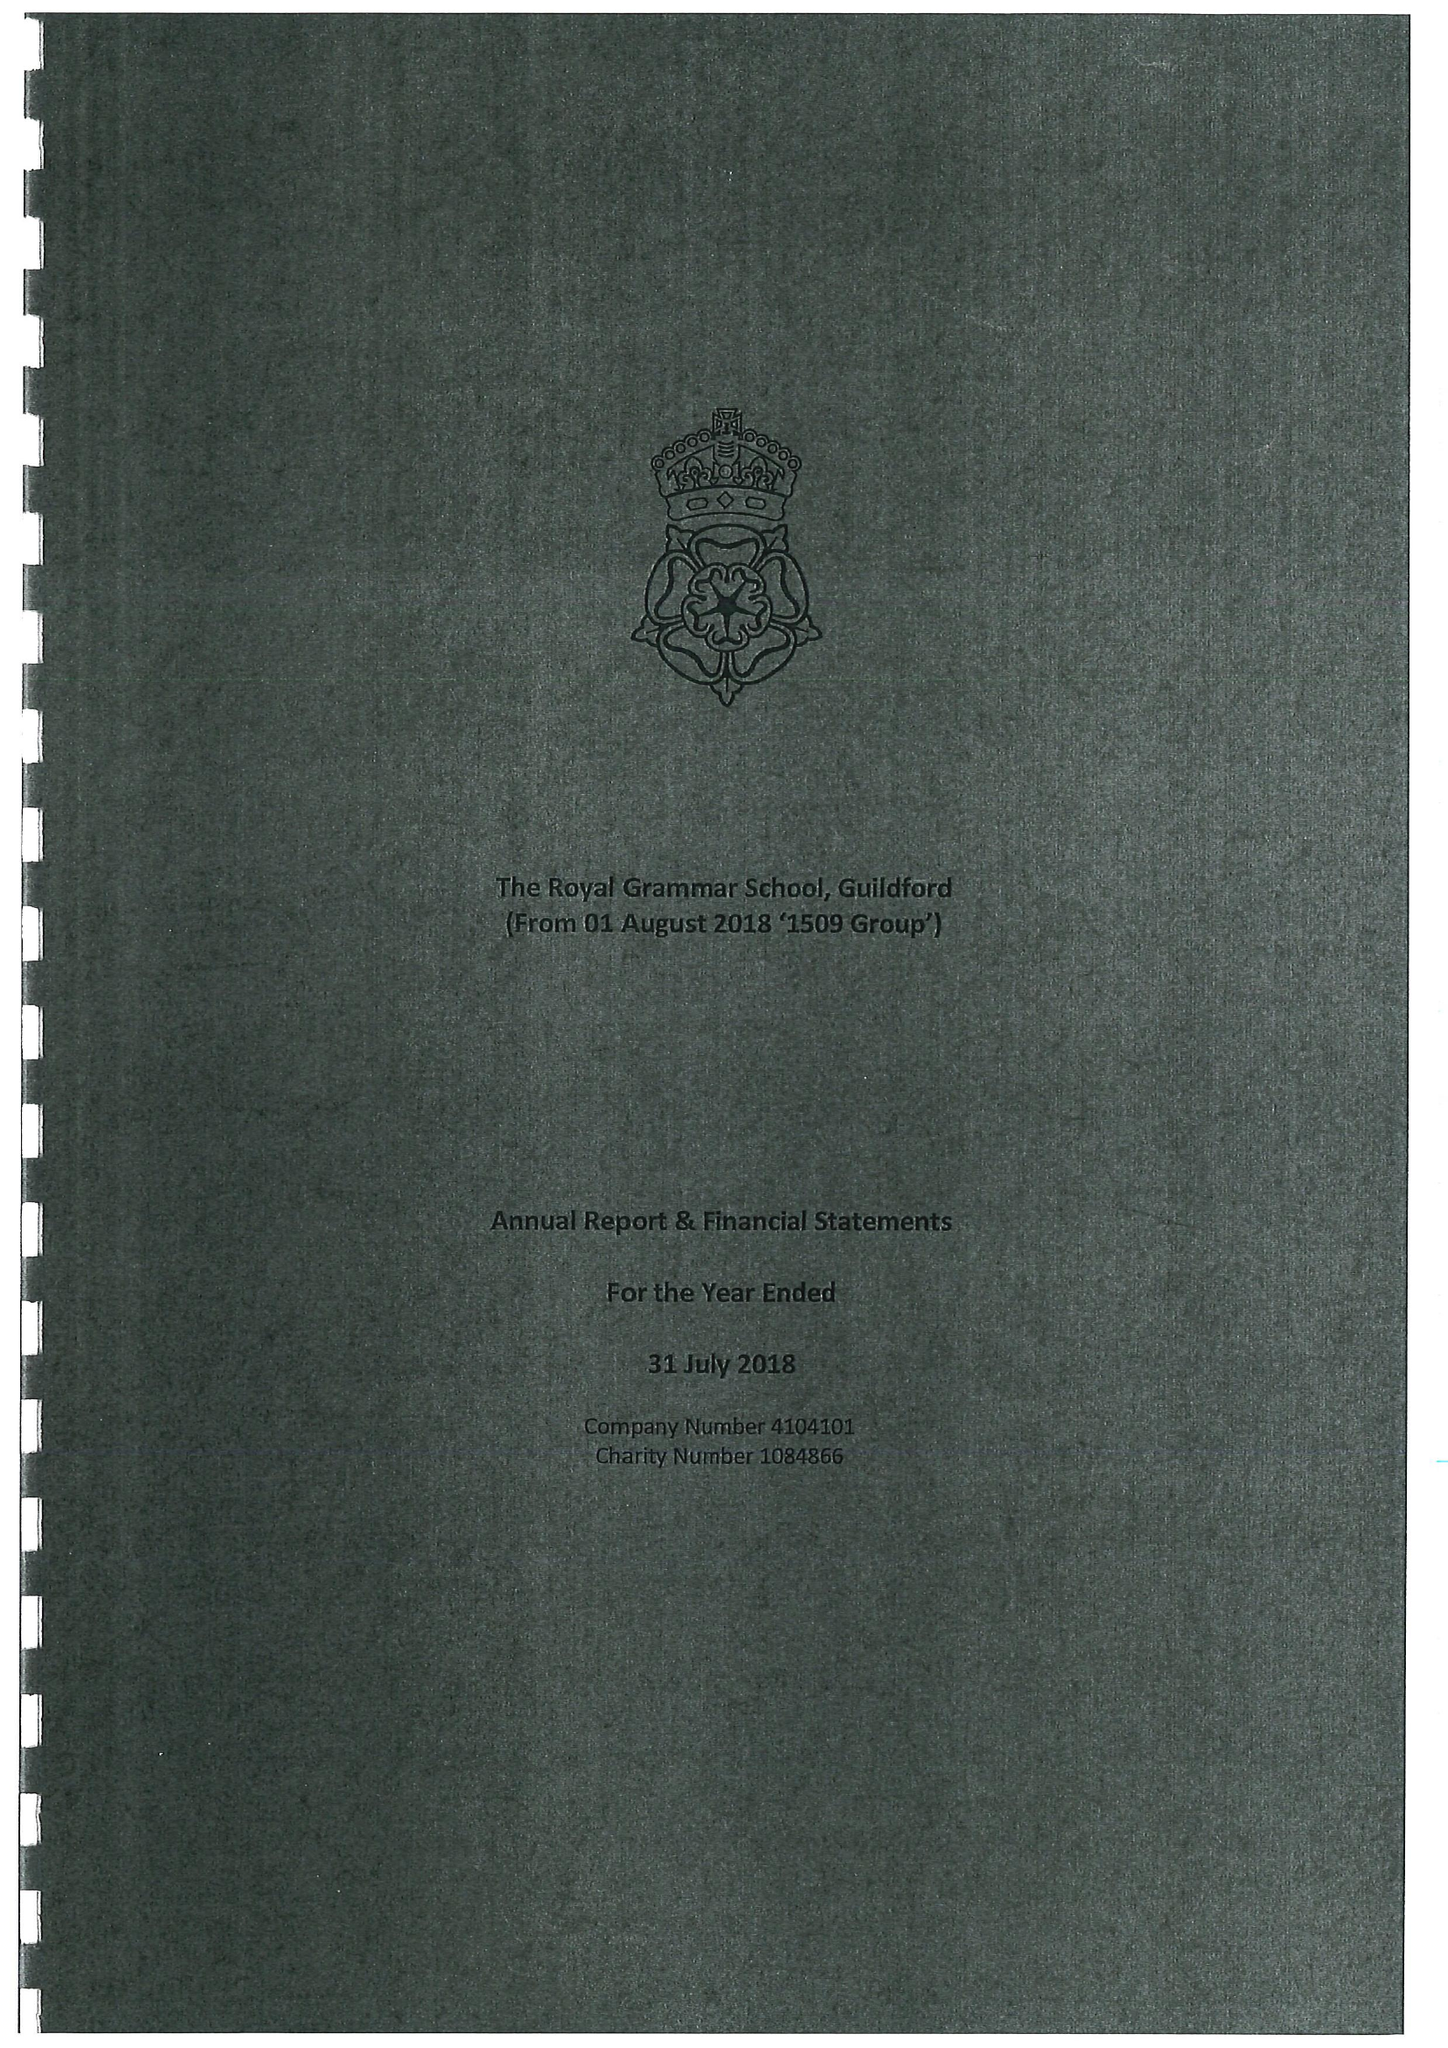What is the value for the report_date?
Answer the question using a single word or phrase. 2018-07-31 